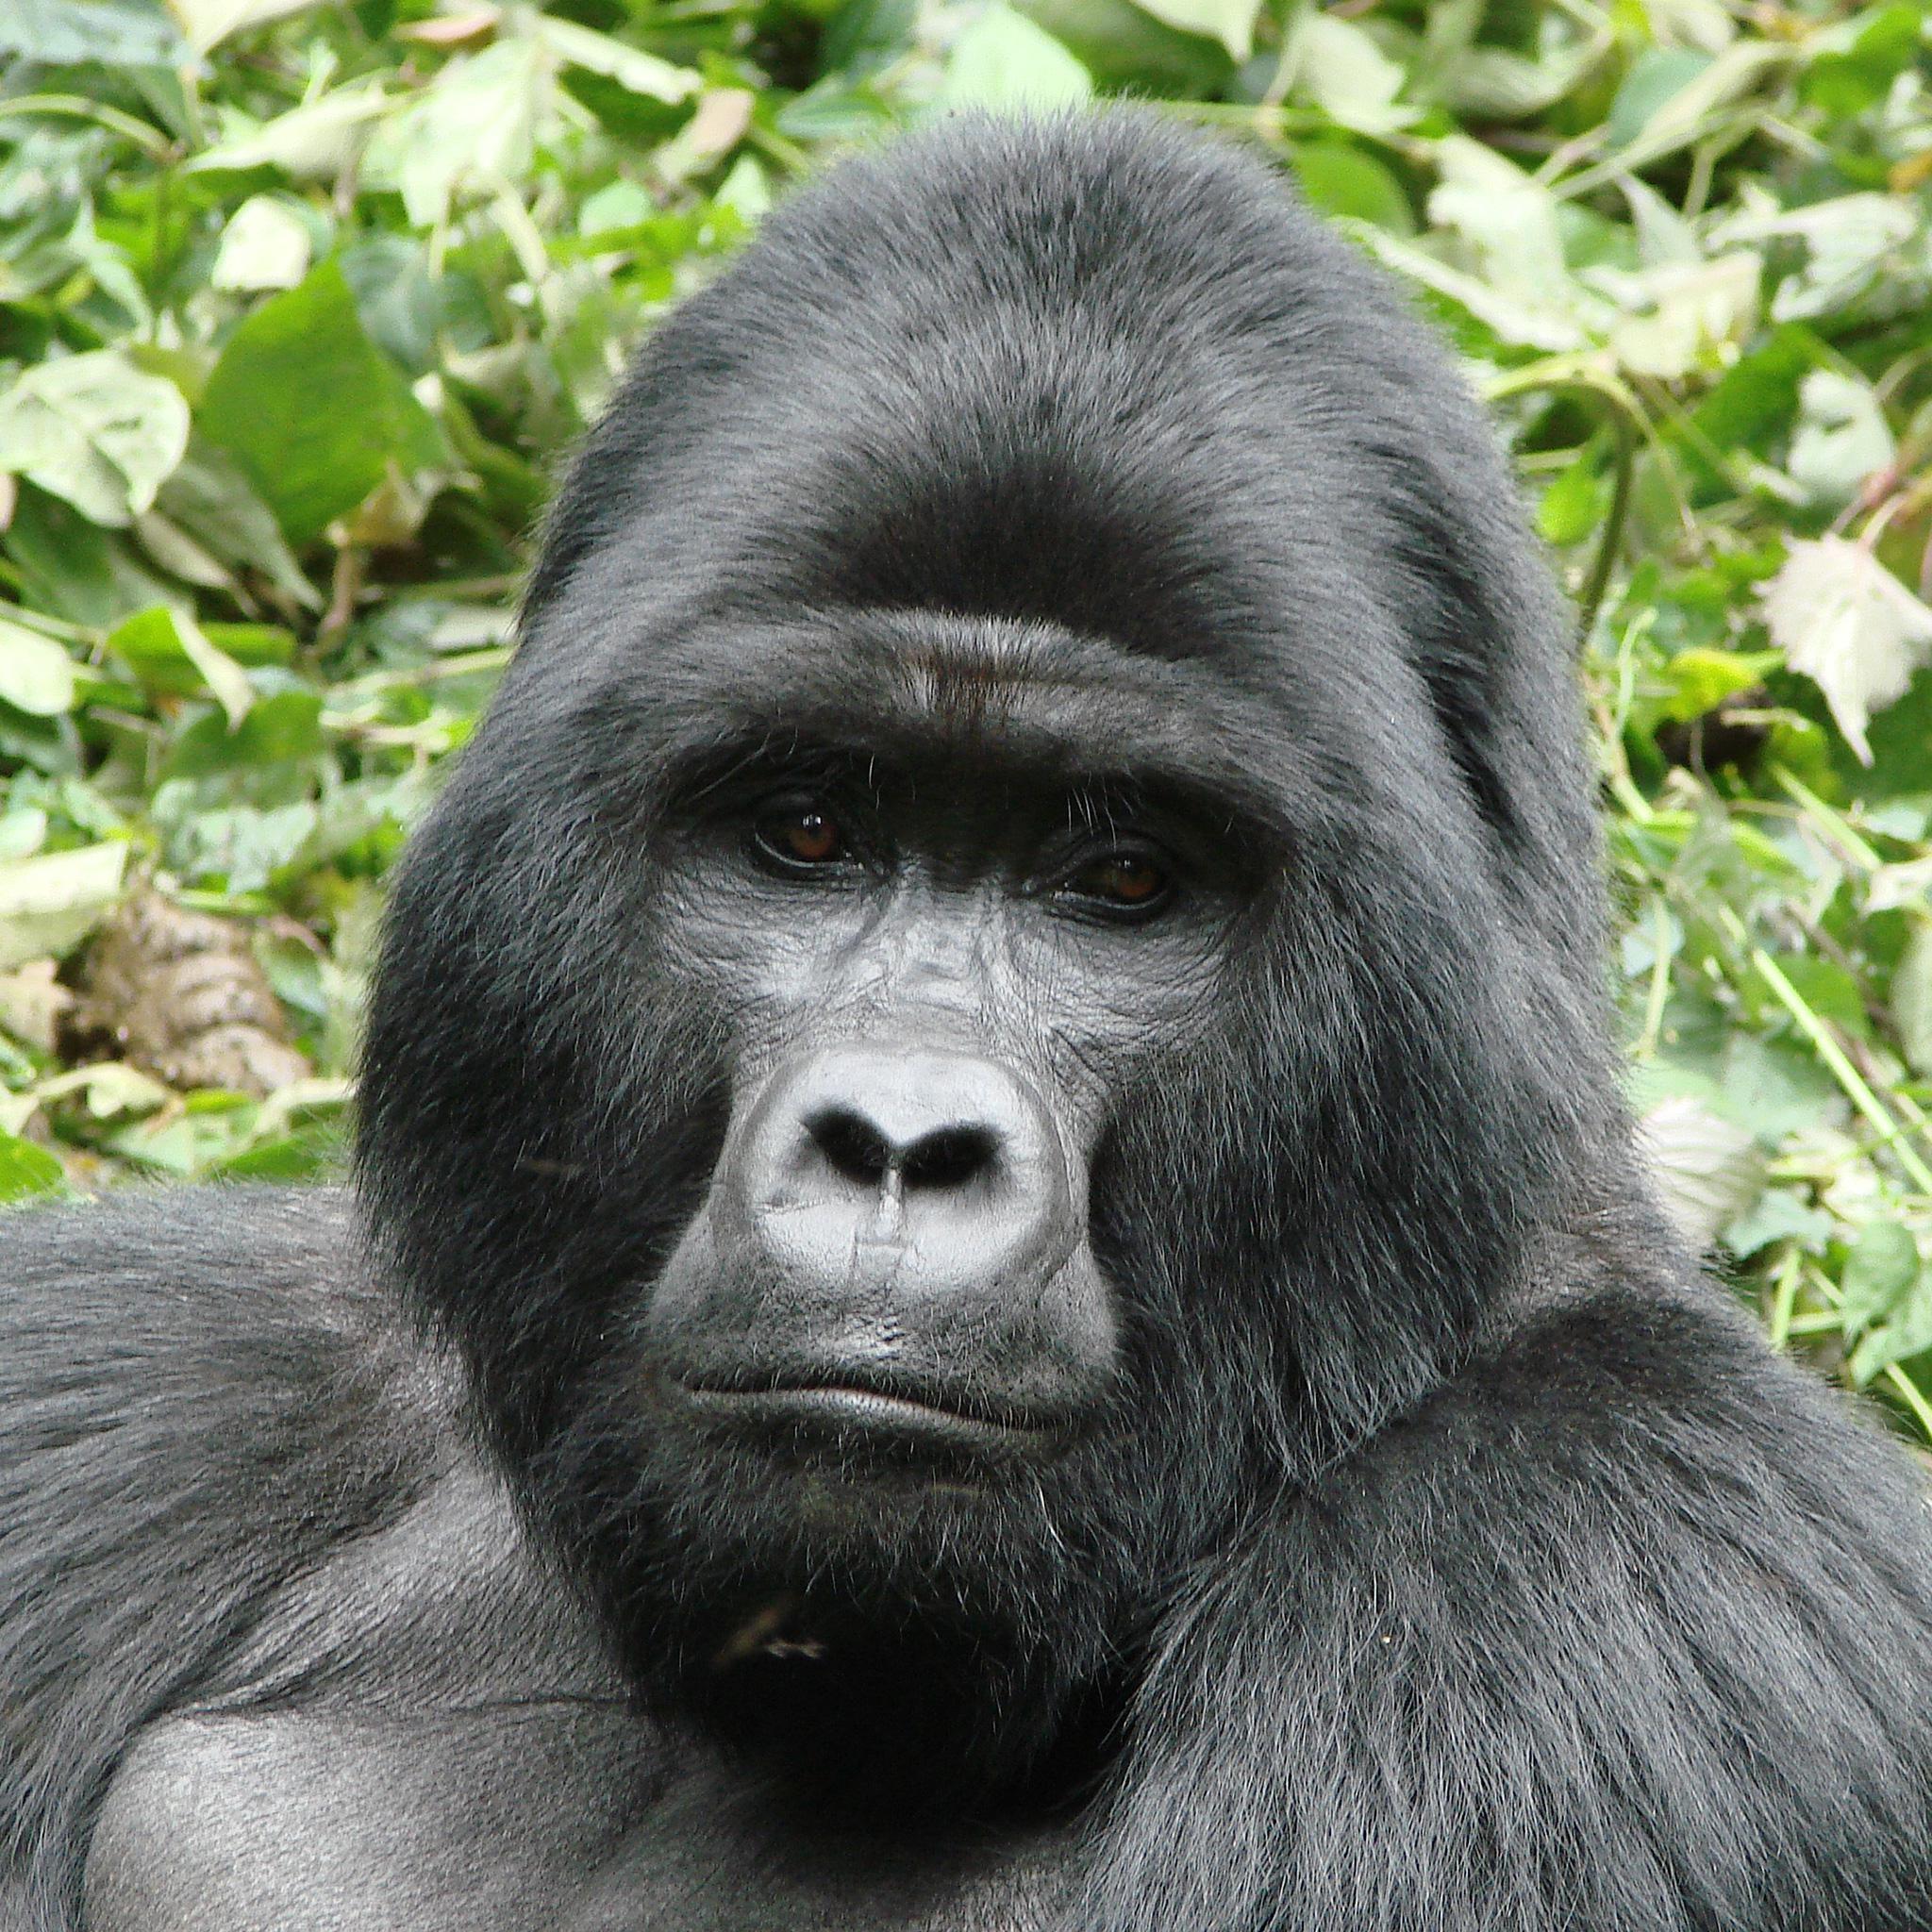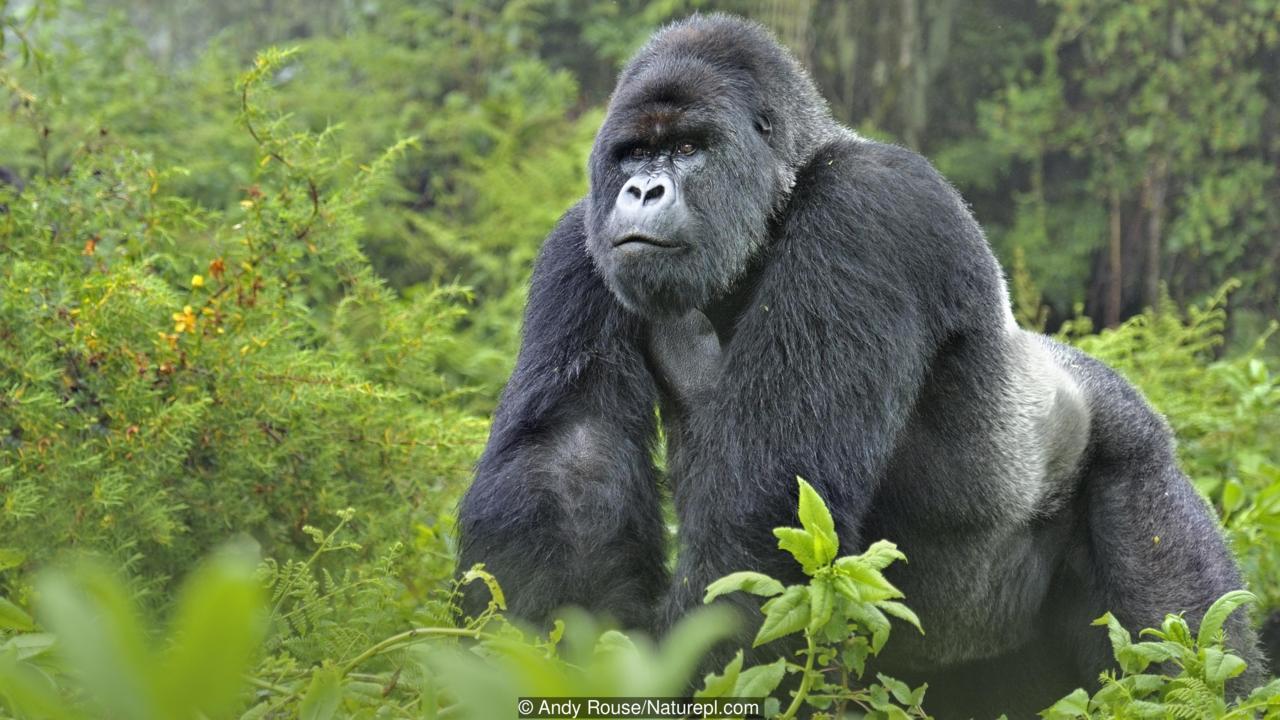The first image is the image on the left, the second image is the image on the right. For the images shown, is this caption "An image shows a baby gorilla with an adult gorilla." true? Answer yes or no. No. 